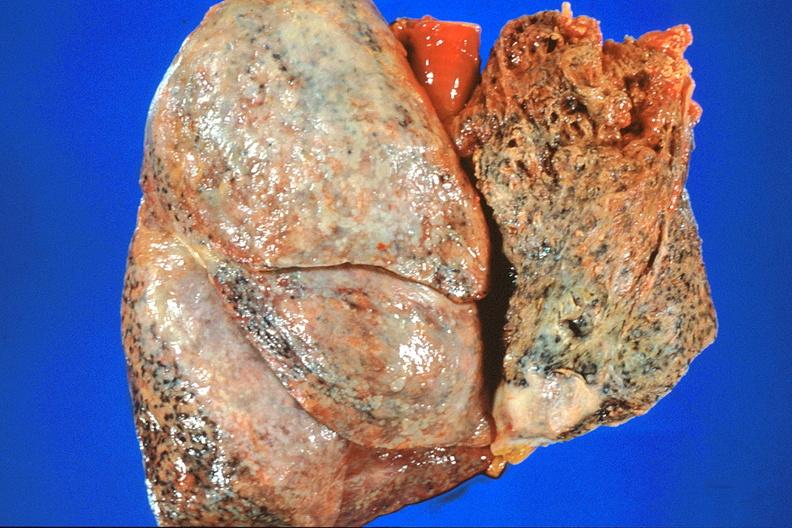what is present?
Answer the question using a single word or phrase. Respiratory 